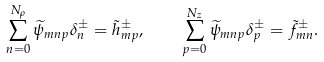Convert formula to latex. <formula><loc_0><loc_0><loc_500><loc_500>\sum _ { n = 0 } ^ { N _ { \rho } } \widetilde { \psi } _ { m n p } \delta _ { n } ^ { \pm } = \tilde { h } ^ { \pm } _ { m p } , \quad \sum _ { p = 0 } ^ { N _ { z } } \widetilde { \psi } _ { m n p } \delta _ { p } ^ { \pm } = \tilde { f } ^ { \pm } _ { m n } .</formula> 